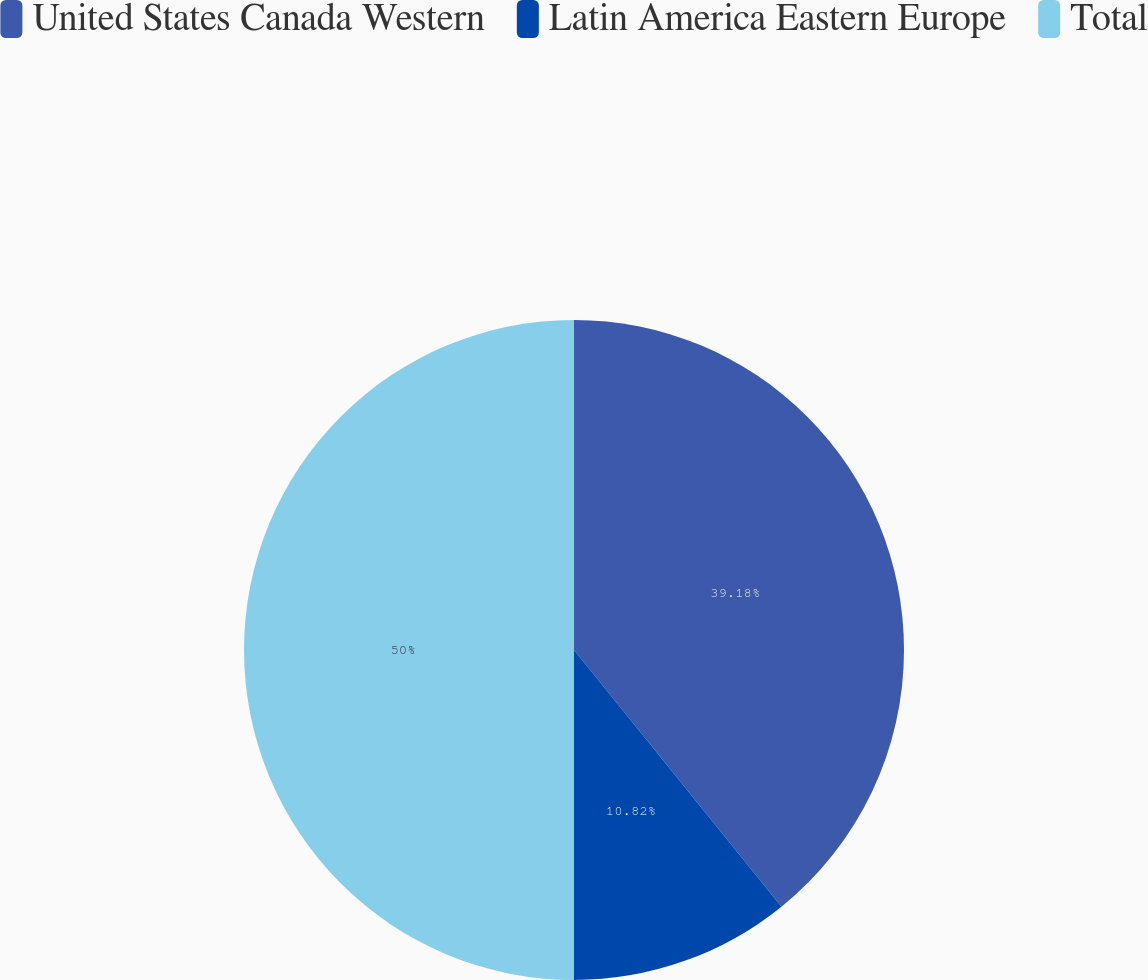Convert chart to OTSL. <chart><loc_0><loc_0><loc_500><loc_500><pie_chart><fcel>United States Canada Western<fcel>Latin America Eastern Europe<fcel>Total<nl><fcel>39.18%<fcel>10.82%<fcel>50.0%<nl></chart> 